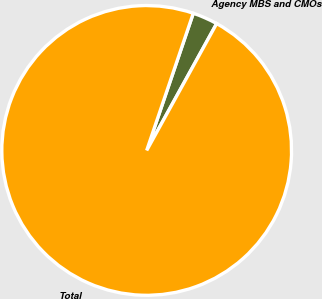Convert chart. <chart><loc_0><loc_0><loc_500><loc_500><pie_chart><fcel>Agency MBS and CMOs<fcel>Total<nl><fcel>2.81%<fcel>97.19%<nl></chart> 